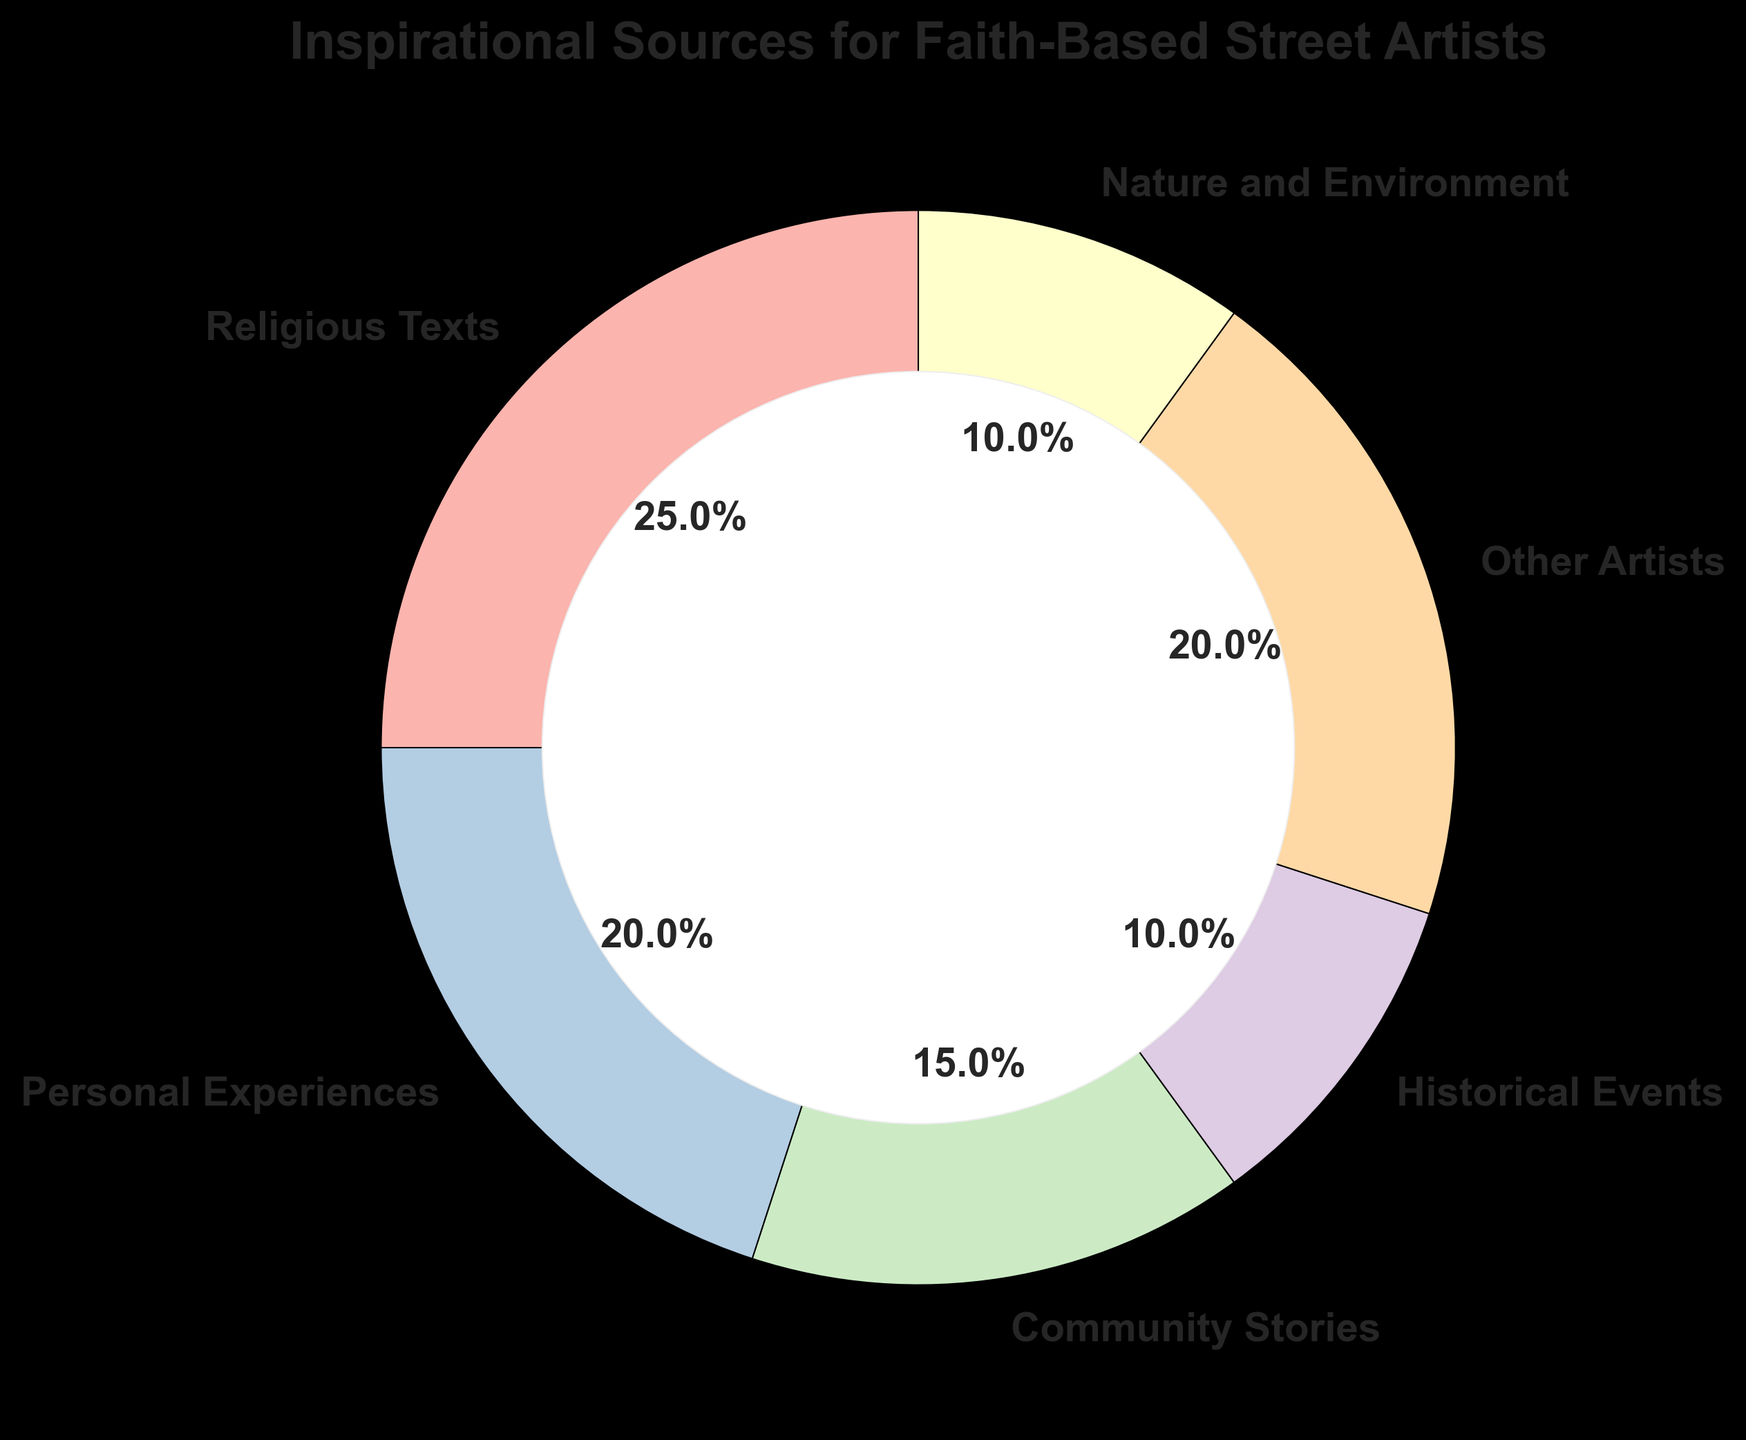What’s the total percentage that comes from other sources than Religious Texts? Adding the percentages of Personal Experiences (20%), Community Stories (15%), Historical Events (10%), Other Artists (20%), and Nature and Environment (10%) gives us 20 + 15 + 10 + 20 + 10 = 75%
Answer: 75% Which source has the highest percentage? From the pie chart, we can see that Religious Texts have the highest percentage at 25%
Answer: Religious Texts What is the combined percentage of Personal Experiences and Other Artists? Adding the percentages of Personal Experiences (20%) and Other Artists (20%) gives us 20 + 20 = 40%
Answer: 40% How does the percentage of Inspirational Sources from Community Stories compare to Historical Events? The percentage from Community Stories (15%) is higher than that from Historical Events (10%)
Answer: Community Stories > Historical Events List the sources that have a percentage greater than 20%. From the pie chart, the only source that has a percentage greater than 20% is Religious Texts (25%)
Answer: Religious Texts What is the percentage difference between the highest and the lowest source? The highest percentage is Religious Texts (25%) and the lowest are Historical Events and Nature and Environment (both 10%). The difference is 25 - 10 = 15%
Answer: 15% Are there any sources with the same percentage? If so, which ones? Yes, Personal Experiences and Other Artists both contribute 20% each to the pie chart
Answer: Personal Experiences and Other Artists What fraction of the pie chart is made up by sources other than Religious Texts and Other Artists? Subtracting the percentages of Religious Texts (25%) and Other Artists (20%) from 100% gives 100 - 25 - 20 = 55%
Answer: 55% What is the visual attribute (color) associated with Religious Texts in the pie chart? The pie chart uses a distinct color for each source. The color associated with Religious Texts should be clearly identifiable (Please refer to the specific chart for the exact color).
Answer: Refer to chart If you sum up the percentages of Community Stories and Nature and Environment, do you get the same percentage as any other source? Adding the percentages of Community Stories (15%) and Nature and Environment (10%) gives us 15 + 10 = 25%, which is equal to the percentage of Religious Texts
Answer: Yes, it's equal to Religious Texts 